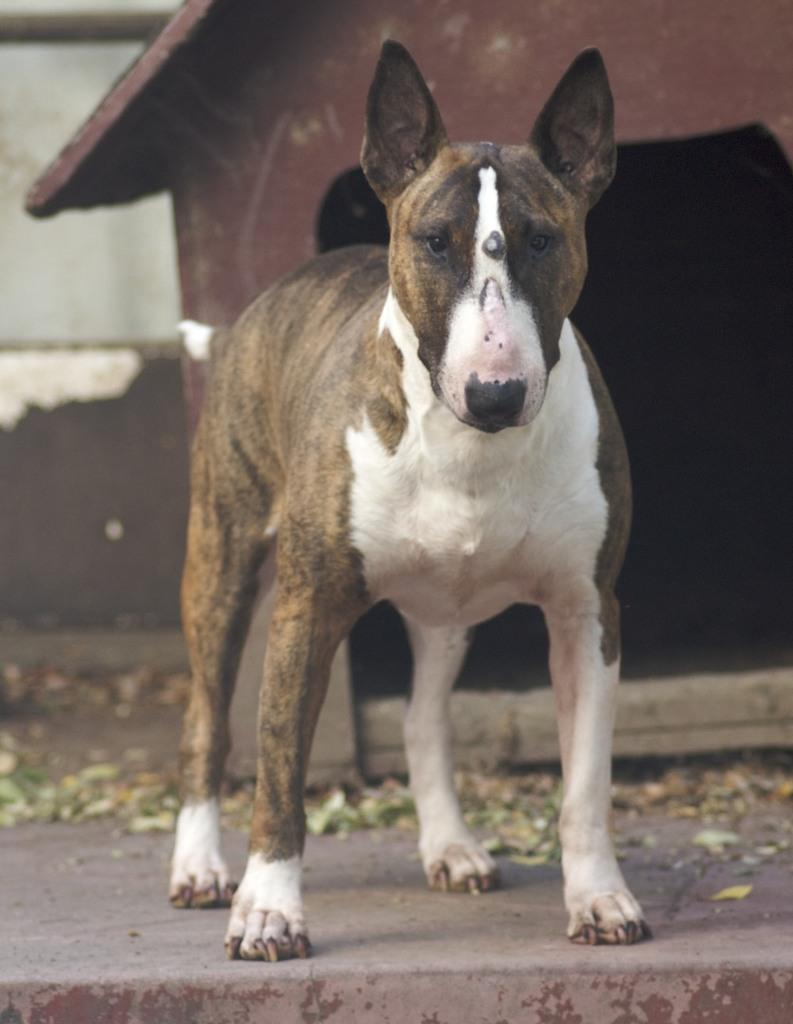What type of animal is in the image? There is a brown and white color dog in the image. Where is the dog positioned in the image? The dog is standing in the front. What is the dog doing in the image? The dog is looking into the camera. Is there any shelter for the dog in the image? Yes, there is a small dog shed house in the image. What type of cork can be seen on the trail in the image? There is no trail or cork present in the image; it features a dog standing in the front and looking into the camera. 